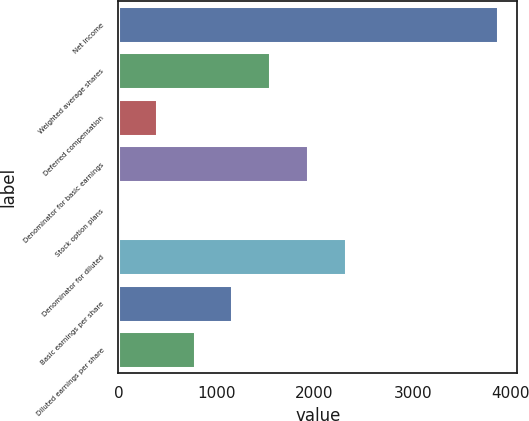<chart> <loc_0><loc_0><loc_500><loc_500><bar_chart><fcel>Net income<fcel>Weighted average shares<fcel>Deferred compensation<fcel>Denominator for basic earnings<fcel>Stock option plans<fcel>Denominator for diluted<fcel>Basic earnings per share<fcel>Diluted earnings per share<nl><fcel>3870<fcel>1549.2<fcel>388.8<fcel>1936<fcel>2<fcel>2322.8<fcel>1162.4<fcel>775.6<nl></chart> 